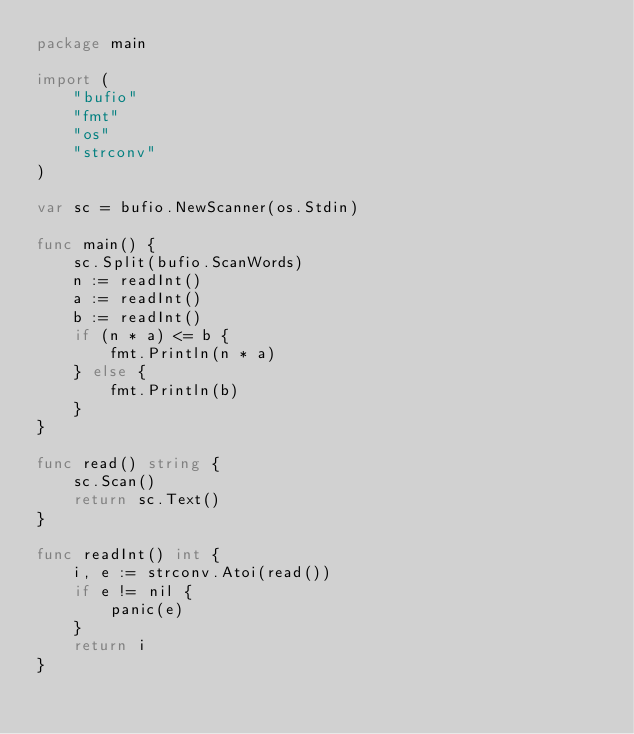Convert code to text. <code><loc_0><loc_0><loc_500><loc_500><_Go_>package main

import (
	"bufio"
	"fmt"
	"os"
	"strconv"
)

var sc = bufio.NewScanner(os.Stdin)

func main() {
	sc.Split(bufio.ScanWords)
	n := readInt()
	a := readInt()
	b := readInt()
	if (n * a) <= b {
		fmt.Println(n * a)
	} else {
		fmt.Println(b)
	}
}

func read() string {
	sc.Scan()
	return sc.Text()
}

func readInt() int {
	i, e := strconv.Atoi(read())
	if e != nil {
		panic(e)
	}
	return i
}
</code> 